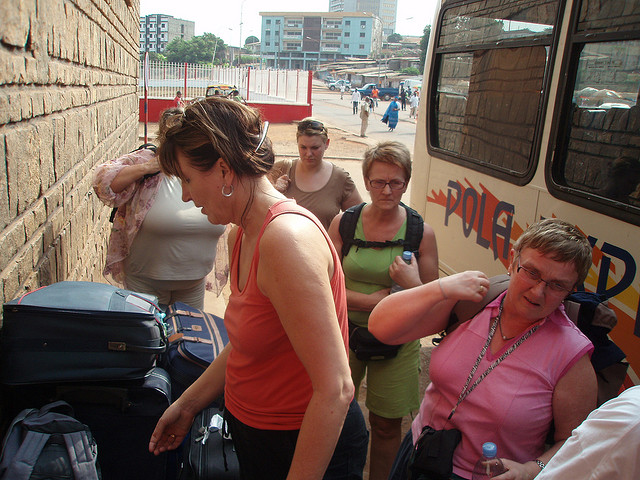Identify and read out the text in this image. POLA 